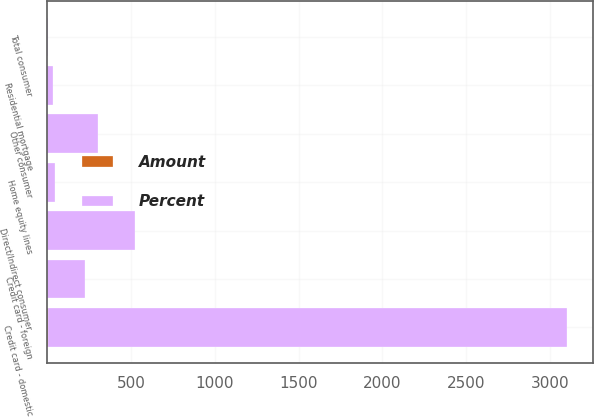Convert chart. <chart><loc_0><loc_0><loc_500><loc_500><stacked_bar_chart><ecel><fcel>Residential mortgage<fcel>Credit card - domestic<fcel>Credit card - foreign<fcel>Home equity lines<fcel>Direct/Indirect consumer<fcel>Other consumer<fcel>Total consumer<nl><fcel>Percent<fcel>39<fcel>3094<fcel>225<fcel>51<fcel>524<fcel>303<fcel>4.85<nl><fcel>Amount<fcel>0.02<fcel>4.85<fcel>2.46<fcel>0.07<fcel>0.88<fcel>2.83<fcel>1.01<nl></chart> 